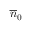<formula> <loc_0><loc_0><loc_500><loc_500>\overline { n } _ { 0 }</formula> 